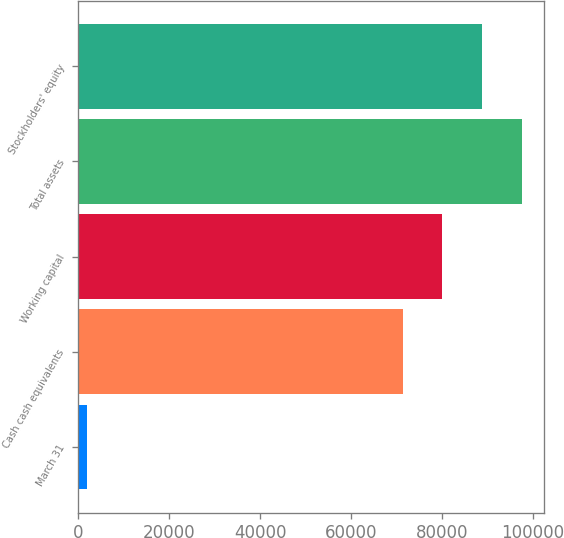Convert chart. <chart><loc_0><loc_0><loc_500><loc_500><bar_chart><fcel>March 31<fcel>Cash cash equivalents<fcel>Working capital<fcel>Total assets<fcel>Stockholders' equity<nl><fcel>2002<fcel>71321<fcel>80038.4<fcel>97473.2<fcel>88755.8<nl></chart> 